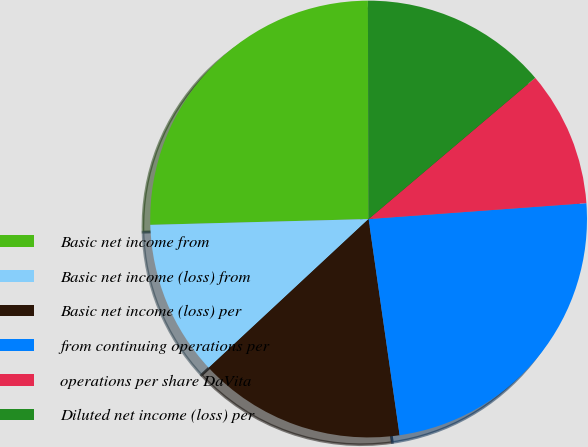Convert chart. <chart><loc_0><loc_0><loc_500><loc_500><pie_chart><fcel>Basic net income from<fcel>Basic net income (loss) from<fcel>Basic net income (loss) per<fcel>from continuing operations per<fcel>operations per share DaVita<fcel>Diluted net income (loss) per<nl><fcel>25.37%<fcel>11.5%<fcel>15.34%<fcel>23.89%<fcel>10.03%<fcel>13.86%<nl></chart> 